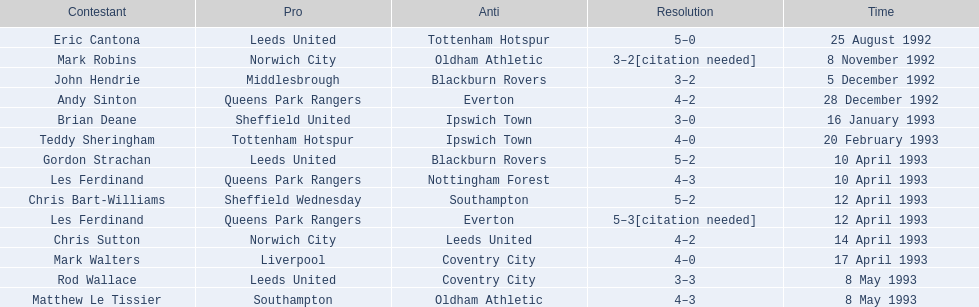What are the results? 5–0, 3–2[citation needed], 3–2, 4–2, 3–0, 4–0, 5–2, 4–3, 5–2, 5–3[citation needed], 4–2, 4–0, 3–3, 4–3. What result did mark robins have? 3–2[citation needed]. What other player had that result? John Hendrie. 